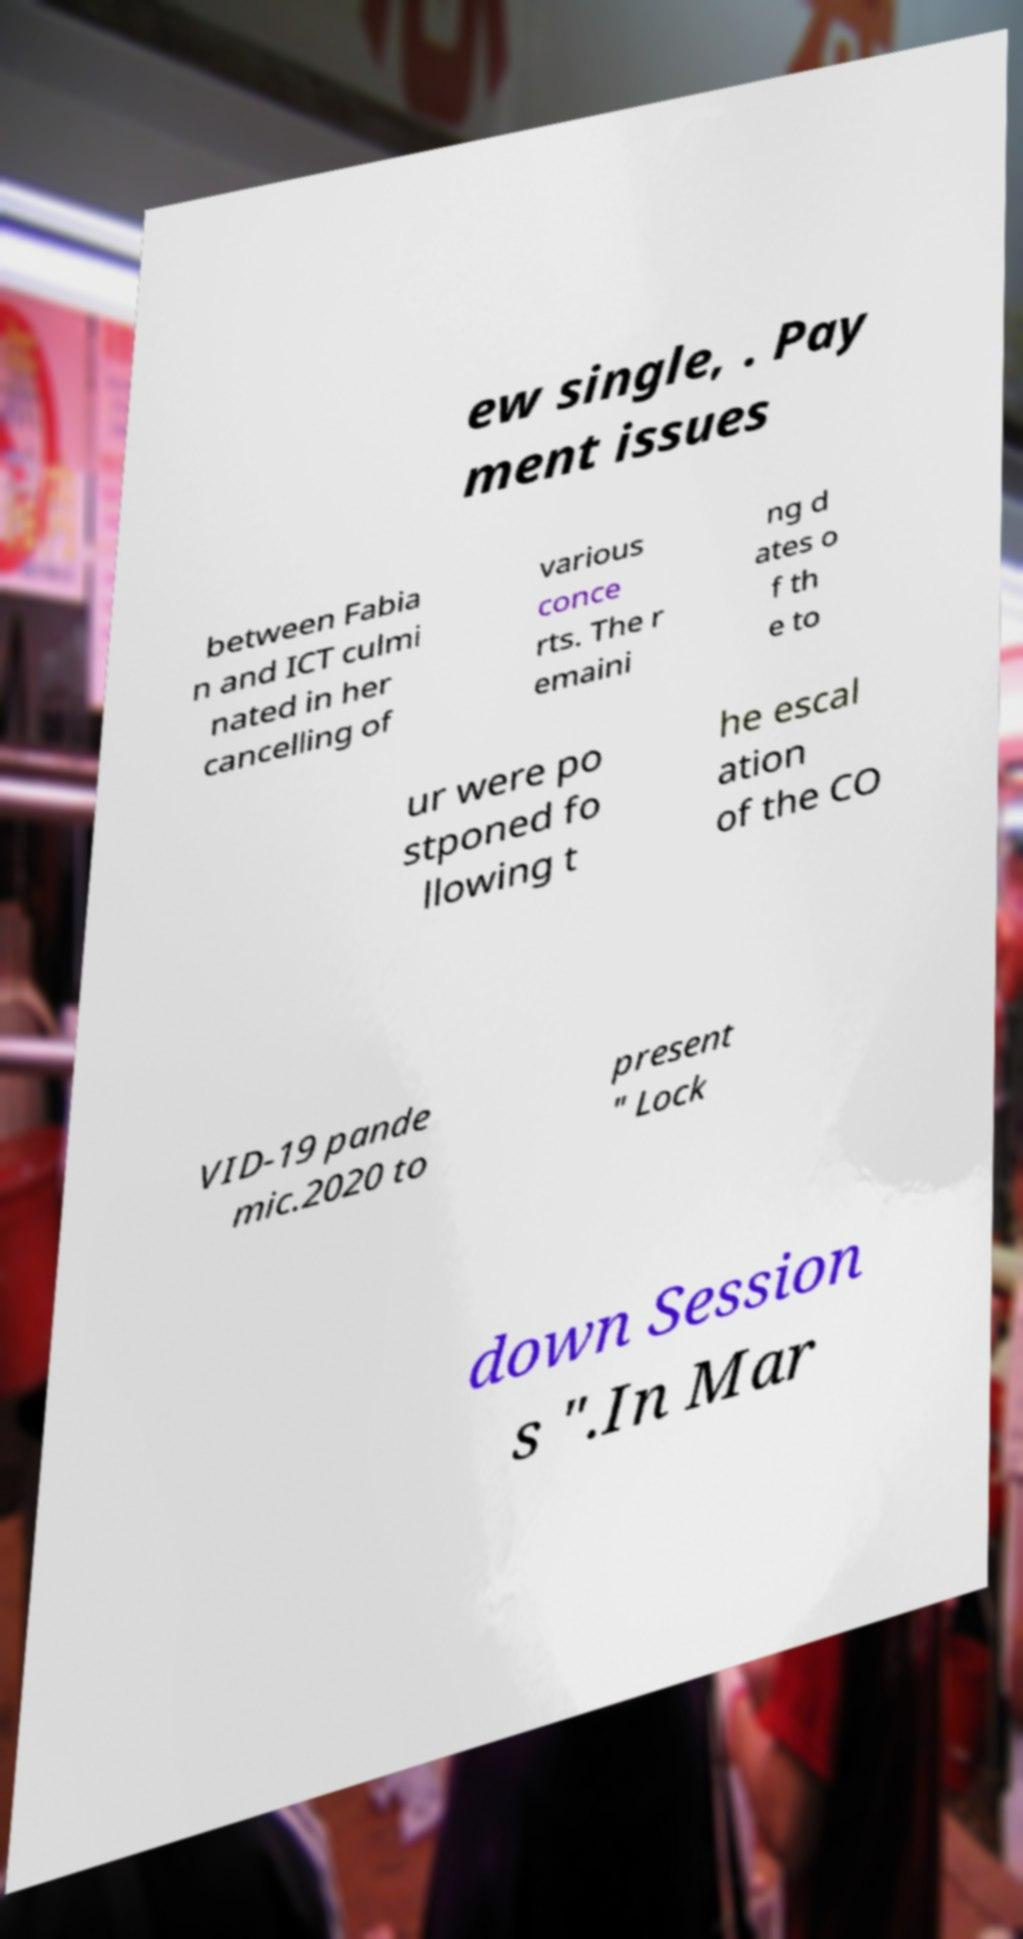I need the written content from this picture converted into text. Can you do that? ew single, . Pay ment issues between Fabia n and ICT culmi nated in her cancelling of various conce rts. The r emaini ng d ates o f th e to ur were po stponed fo llowing t he escal ation of the CO VID-19 pande mic.2020 to present " Lock down Session s ".In Mar 